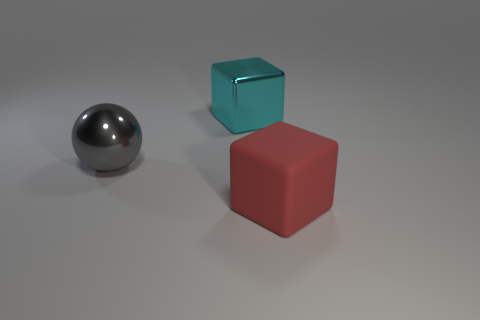Does the large cyan metal object have the same shape as the large gray thing?
Give a very brief answer. No. What number of objects are either big blocks in front of the metal sphere or small yellow matte things?
Offer a terse response. 1. Are there the same number of big gray spheres that are behind the big shiny sphere and gray balls that are to the right of the red rubber object?
Provide a succinct answer. Yes. What number of other objects are there of the same shape as the gray shiny thing?
Offer a terse response. 0. There is a block that is on the left side of the big red matte block; does it have the same size as the object in front of the big gray object?
Your response must be concise. Yes. What number of spheres are gray metallic objects or cyan shiny objects?
Give a very brief answer. 1. What number of metallic things are either big red objects or blue cylinders?
Make the answer very short. 0. The cyan metallic thing that is the same shape as the red rubber thing is what size?
Keep it short and to the point. Large. Is there anything else that is the same size as the ball?
Provide a short and direct response. Yes. There is a red rubber cube; is its size the same as the shiny thing that is in front of the large metal block?
Make the answer very short. Yes. 